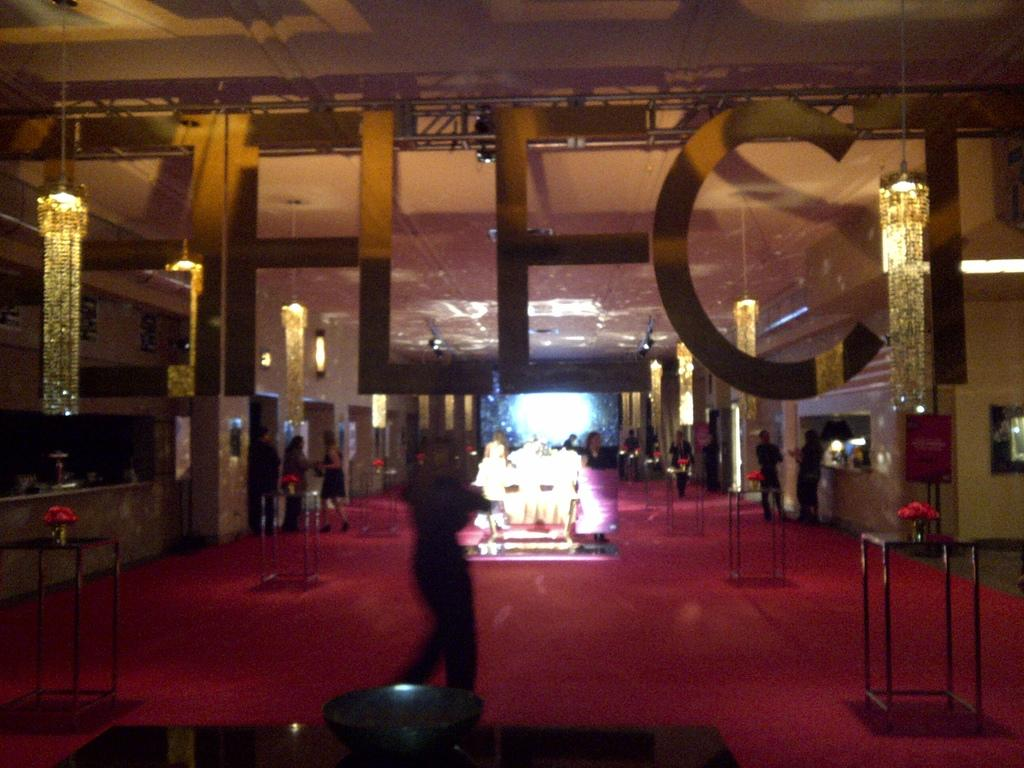How many people can be seen in the image? There are people in the image, but the exact number cannot be determined from the provided facts. What type of furniture is present in the image? There are tables in the image. What decorative items can be seen on the tables? Flower vases are present in the image. What is the color of the surface in the image? The surface in the image is red. What architectural features can be seen in the background of the image? There is a wall, lights, objects, banners, and the ceiling visible in the background of the image. Is there any text visible in the image? Yes, there is some text visible in the image. What type of bread is being served for breakfast in the image? There is no bread or breakfast depicted in the image. Who is the guide leading the group in the image? There is no guide or group present in the image. 